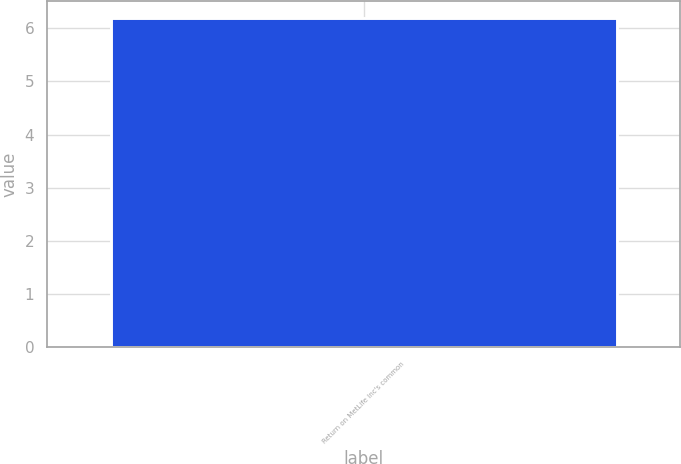Convert chart to OTSL. <chart><loc_0><loc_0><loc_500><loc_500><bar_chart><fcel>Return on MetLife Inc's common<nl><fcel>6.2<nl></chart> 